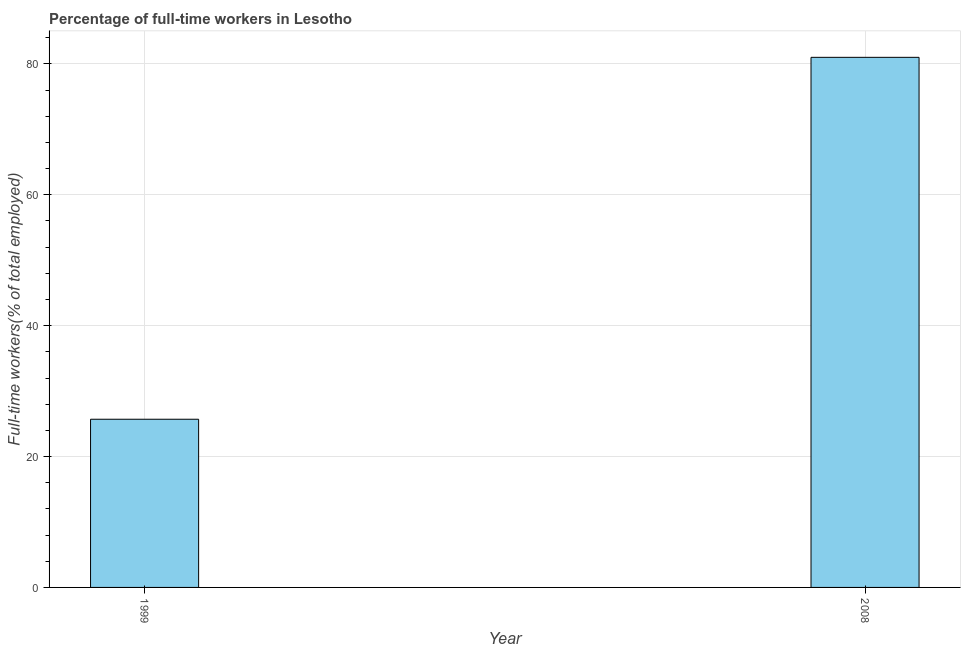Does the graph contain grids?
Provide a succinct answer. Yes. What is the title of the graph?
Offer a very short reply. Percentage of full-time workers in Lesotho. What is the label or title of the X-axis?
Provide a short and direct response. Year. What is the label or title of the Y-axis?
Offer a very short reply. Full-time workers(% of total employed). Across all years, what is the minimum percentage of full-time workers?
Provide a short and direct response. 25.7. In which year was the percentage of full-time workers minimum?
Offer a terse response. 1999. What is the sum of the percentage of full-time workers?
Provide a short and direct response. 106.7. What is the difference between the percentage of full-time workers in 1999 and 2008?
Give a very brief answer. -55.3. What is the average percentage of full-time workers per year?
Provide a succinct answer. 53.35. What is the median percentage of full-time workers?
Keep it short and to the point. 53.35. In how many years, is the percentage of full-time workers greater than 76 %?
Offer a very short reply. 1. Do a majority of the years between 1999 and 2008 (inclusive) have percentage of full-time workers greater than 36 %?
Give a very brief answer. No. What is the ratio of the percentage of full-time workers in 1999 to that in 2008?
Your response must be concise. 0.32. How many bars are there?
Provide a succinct answer. 2. What is the difference between two consecutive major ticks on the Y-axis?
Your answer should be compact. 20. Are the values on the major ticks of Y-axis written in scientific E-notation?
Provide a succinct answer. No. What is the Full-time workers(% of total employed) in 1999?
Offer a terse response. 25.7. What is the difference between the Full-time workers(% of total employed) in 1999 and 2008?
Your response must be concise. -55.3. What is the ratio of the Full-time workers(% of total employed) in 1999 to that in 2008?
Ensure brevity in your answer.  0.32. 